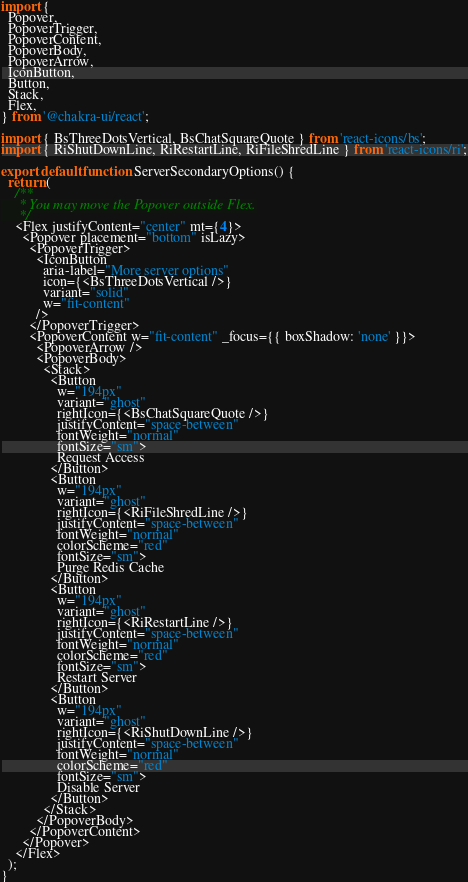Convert code to text. <code><loc_0><loc_0><loc_500><loc_500><_TypeScript_>import {
  Popover,
  PopoverTrigger,
  PopoverContent,
  PopoverBody,
  PopoverArrow,
  IconButton,
  Button,
  Stack,
  Flex,
} from '@chakra-ui/react';

import { BsThreeDotsVertical, BsChatSquareQuote } from 'react-icons/bs';
import { RiShutDownLine, RiRestartLine, RiFileShredLine } from 'react-icons/ri';

export default function ServerSecondaryOptions() {
  return (
    /**
     * You may move the Popover outside Flex.
     */
    <Flex justifyContent="center" mt={4}>
      <Popover placement="bottom" isLazy>
        <PopoverTrigger>
          <IconButton
            aria-label="More server options"
            icon={<BsThreeDotsVertical />}
            variant="solid"
            w="fit-content"
          />
        </PopoverTrigger>
        <PopoverContent w="fit-content" _focus={{ boxShadow: 'none' }}>
          <PopoverArrow />
          <PopoverBody>
            <Stack>
              <Button
                w="194px"
                variant="ghost"
                rightIcon={<BsChatSquareQuote />}
                justifyContent="space-between"
                fontWeight="normal"
                fontSize="sm">
                Request Access
              </Button>
              <Button
                w="194px"
                variant="ghost"
                rightIcon={<RiFileShredLine />}
                justifyContent="space-between"
                fontWeight="normal"
                colorScheme="red"
                fontSize="sm">
                Purge Redis Cache
              </Button>
              <Button
                w="194px"
                variant="ghost"
                rightIcon={<RiRestartLine />}
                justifyContent="space-between"
                fontWeight="normal"
                colorScheme="red"
                fontSize="sm">
                Restart Server
              </Button>
              <Button
                w="194px"
                variant="ghost"
                rightIcon={<RiShutDownLine />}
                justifyContent="space-between"
                fontWeight="normal"
                colorScheme="red"
                fontSize="sm">
                Disable Server
              </Button>
            </Stack>
          </PopoverBody>
        </PopoverContent>
      </Popover>
    </Flex>
  );
}
</code> 